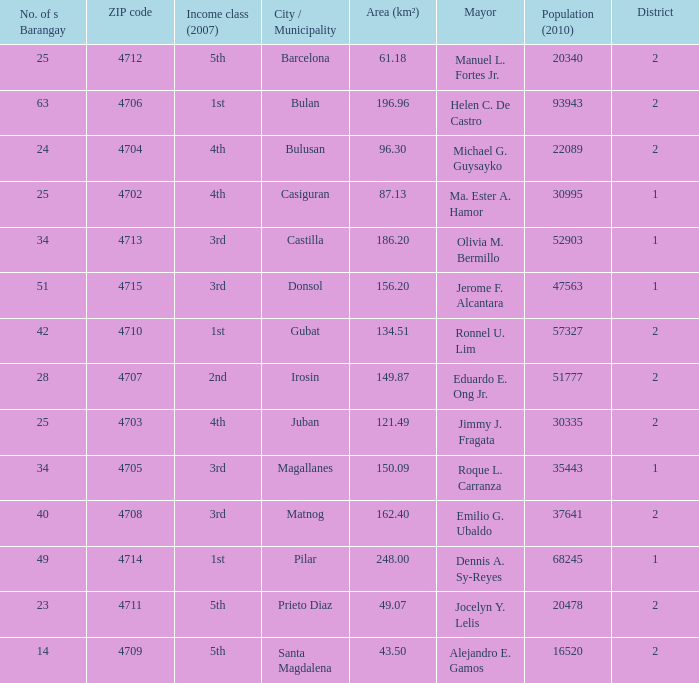What are all the metropolis / municipality where mayor is helen c. De castro Bulan. 